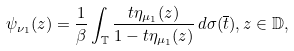Convert formula to latex. <formula><loc_0><loc_0><loc_500><loc_500>\psi _ { \nu _ { 1 } } ( z ) = \frac { 1 } { \beta } \int _ { \mathbb { T } } \frac { t \eta _ { \mu _ { 1 } } ( z ) } { 1 - t \eta _ { \mu _ { 1 } } ( z ) } \, d \sigma ( \overline { t } ) , z \in \mathbb { D } ,</formula> 